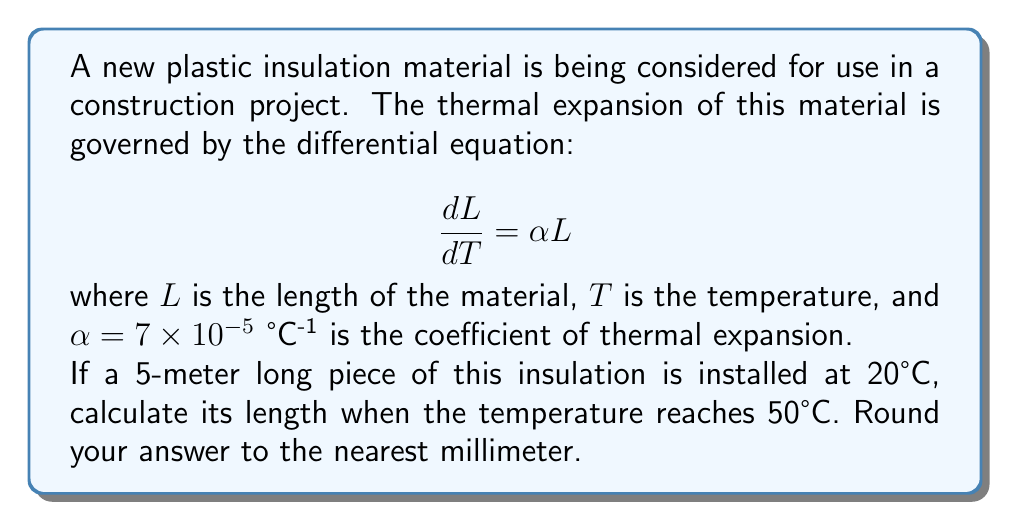Show me your answer to this math problem. To solve this problem, we need to use the given first-order differential equation and integrate it.

1) The differential equation is:
   $$\frac{dL}{dT} = \alpha L$$

2) Rearranging the equation:
   $$\frac{dL}{L} = \alpha dT$$

3) Integrating both sides:
   $$\int_{L_0}^{L} \frac{dL}{L} = \int_{T_0}^{T} \alpha dT$$

4) Solving the integrals:
   $$[\ln L]_{L_0}^{L} = \alpha [T]_{T_0}^{T}$$

5) Evaluating the limits:
   $$\ln L - \ln L_0 = \alpha(T - T_0)$$

6) Using the properties of logarithms:
   $$\ln \frac{L}{L_0} = \alpha(T - T_0)$$

7) Exponentiating both sides:
   $$\frac{L}{L_0} = e^{\alpha(T - T_0)}$$

8) Solving for L:
   $$L = L_0 e^{\alpha(T - T_0)}$$

9) Plugging in the values:
   $L_0 = 5$ m
   $\alpha = 7 \times 10^{-5}$ °C^(-1)
   $T = 50$ °C
   $T_0 = 20$ °C

   $$L = 5 \cdot e^{7 \times 10^{-5}(50 - 20)}$$

10) Calculating:
    $$L = 5 \cdot e^{7 \times 10^{-5} \cdot 30} = 5 \cdot e^{0.0021} = 5 \cdot 1.002103 = 5.010515 \text{ m}$$

11) Rounding to the nearest millimeter:
    $L \approx 5.011$ m
Answer: 5.011 m 